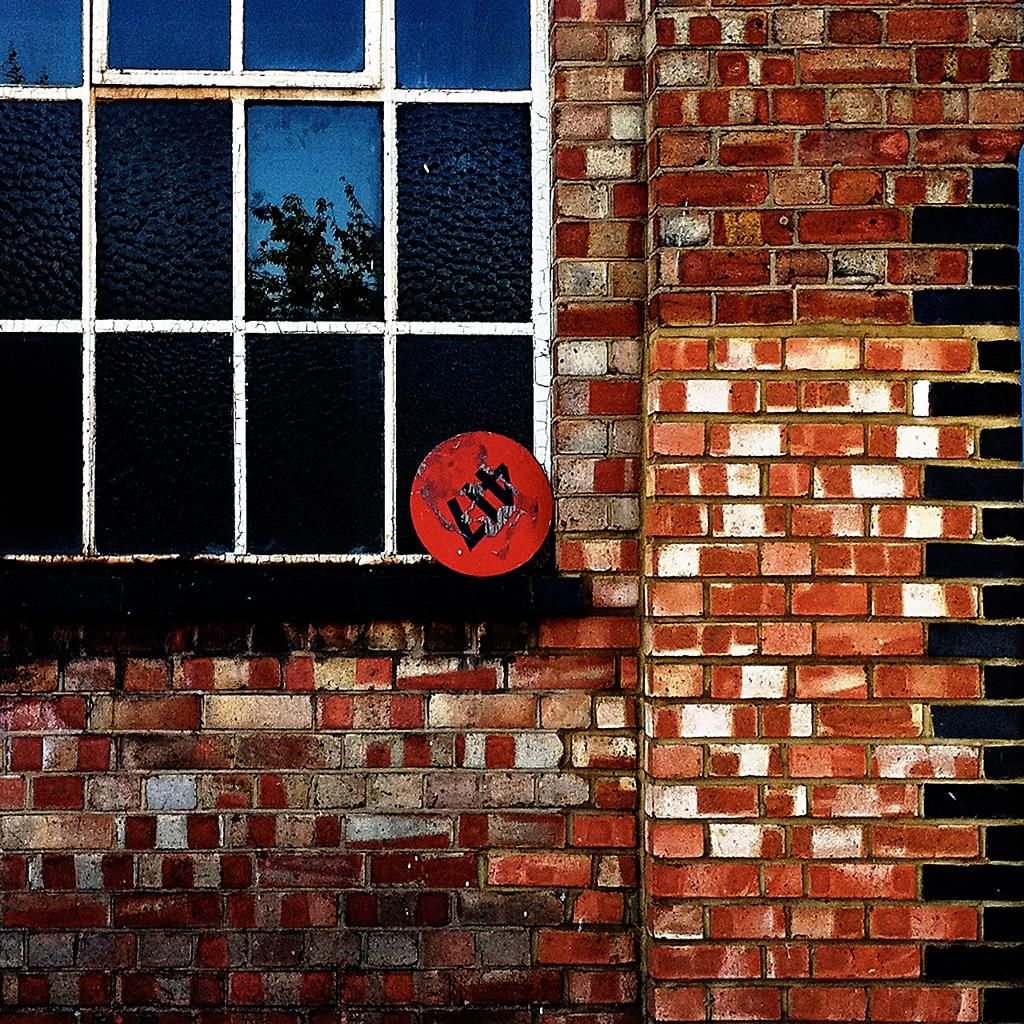What type of structure is visible in the image? There is a glass window in the image. What material is the wall connected to the glass window made of? The wall connected to the glass window is made of brick. How many toes can be seen on the train tracks in the image? There are no train tracks or toes present in the image; it features a glass window connected to a brick wall. 